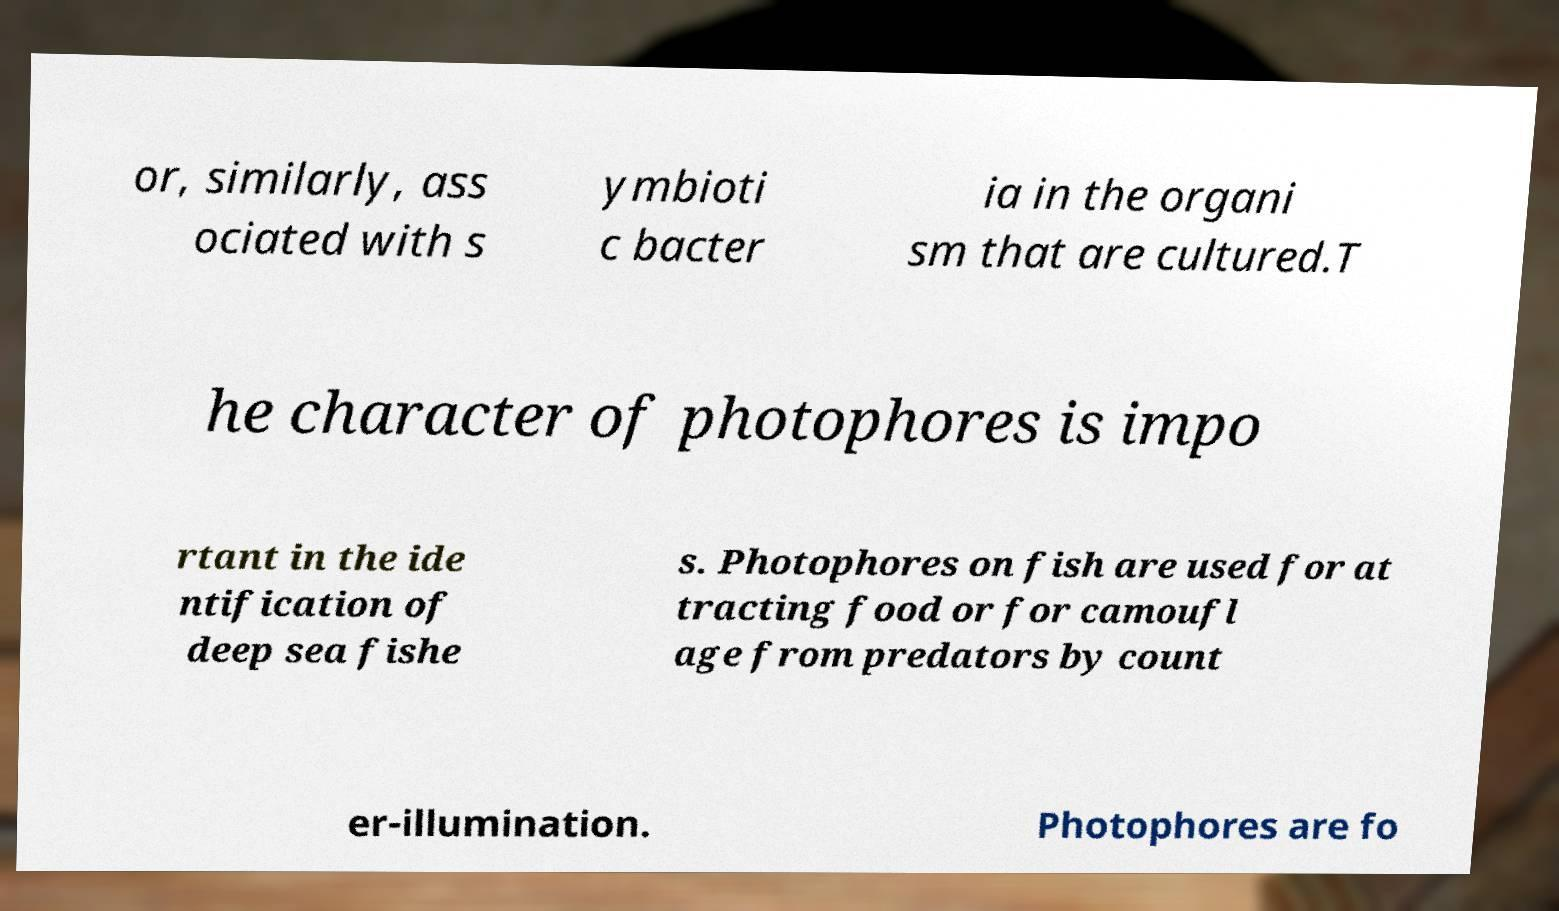Could you assist in decoding the text presented in this image and type it out clearly? or, similarly, ass ociated with s ymbioti c bacter ia in the organi sm that are cultured.T he character of photophores is impo rtant in the ide ntification of deep sea fishe s. Photophores on fish are used for at tracting food or for camoufl age from predators by count er-illumination. Photophores are fo 